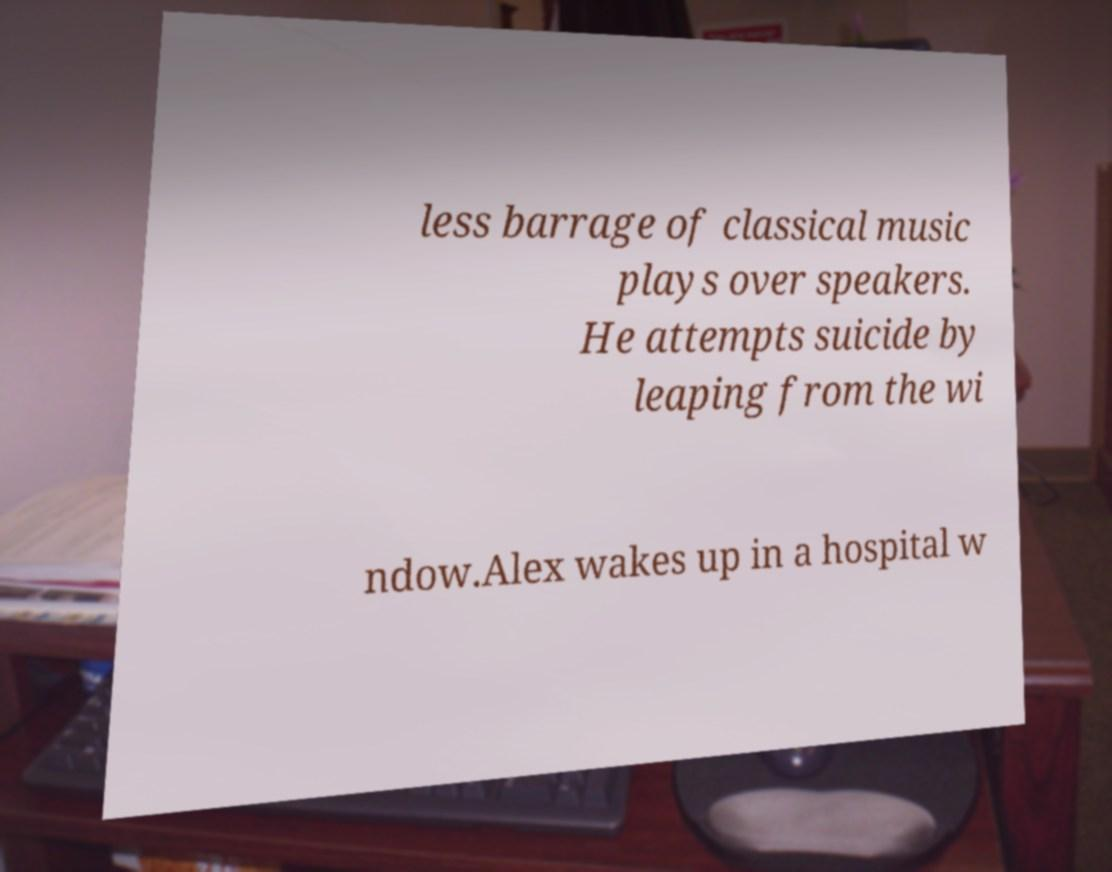Please read and relay the text visible in this image. What does it say? less barrage of classical music plays over speakers. He attempts suicide by leaping from the wi ndow.Alex wakes up in a hospital w 